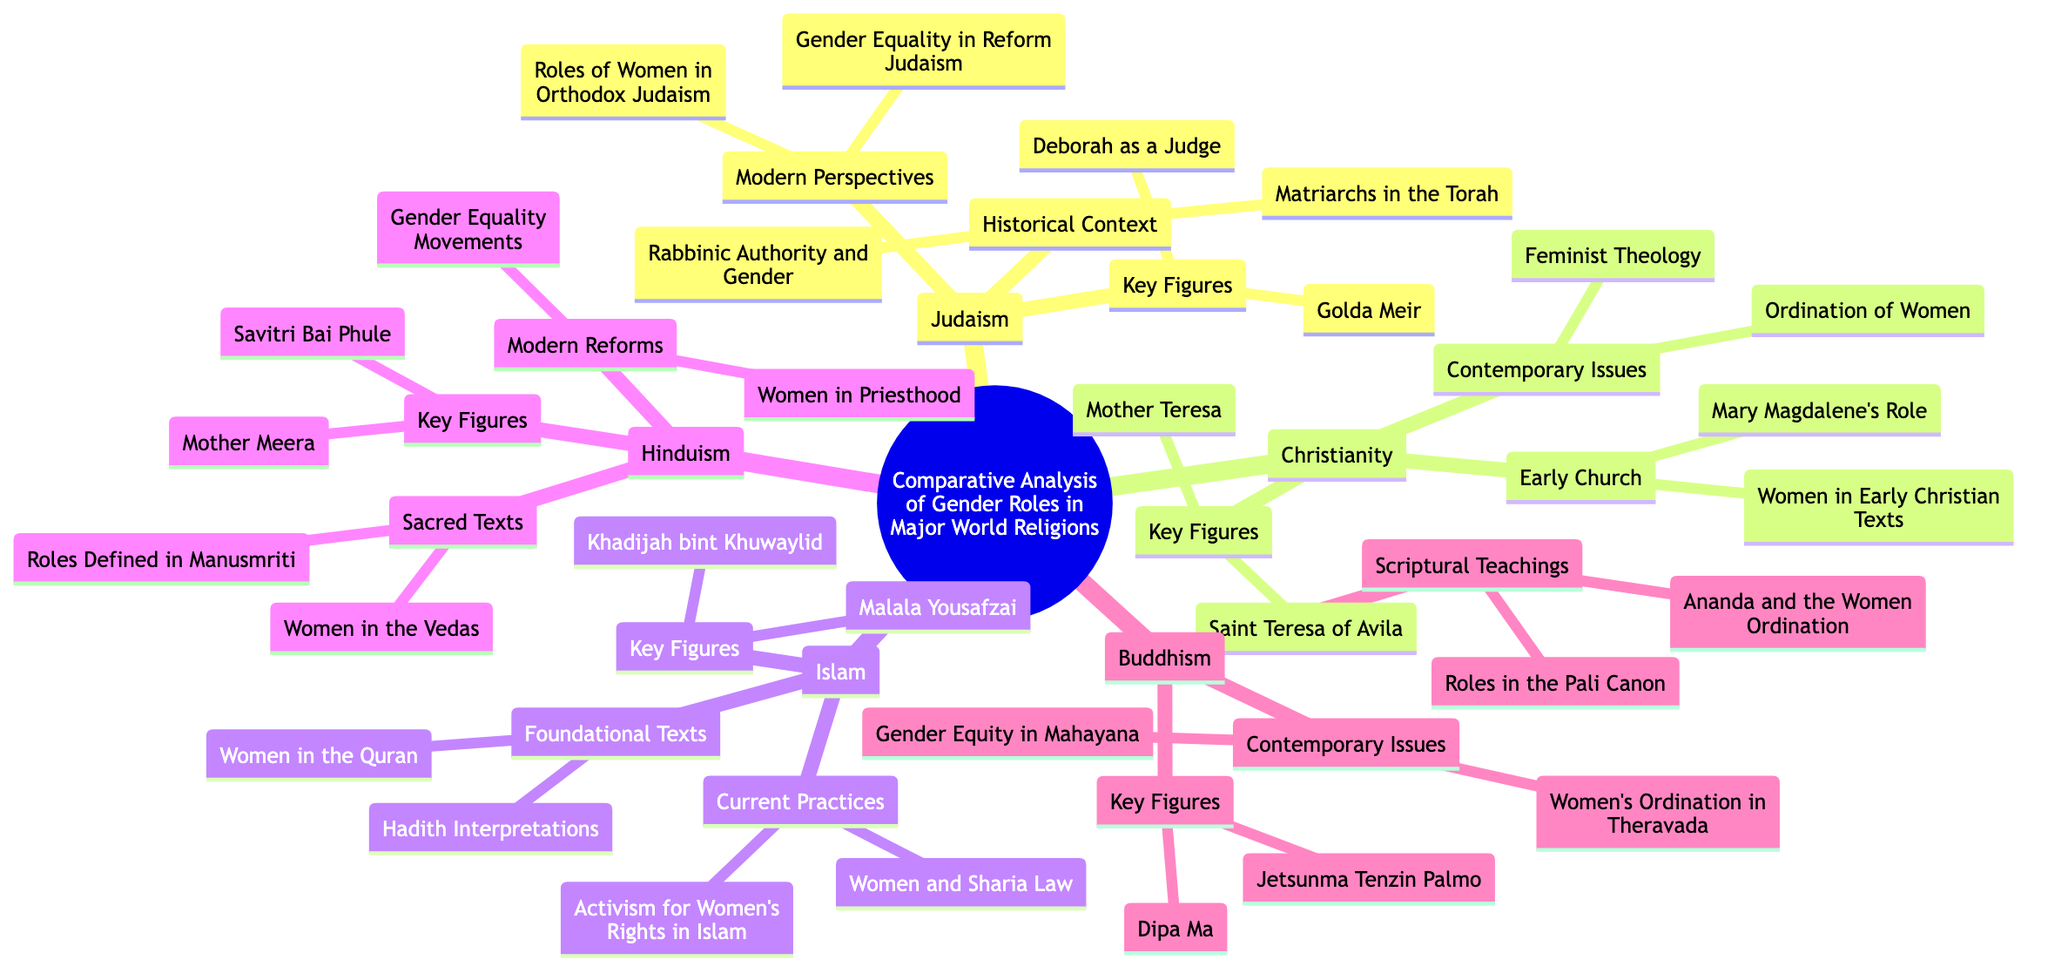What are the key figures in Christianity? To find the key figures within the Christianity branch, I look for the sub-branch labeled "Key Figures." In that sub-branch, the names listed are "Saint Teresa of Avila" and "Mother Teresa."
Answer: Saint Teresa of Avila, Mother Teresa How many major world religions are analyzed in this mind map? I need to count the main branches starting from the root. There are five branches (Judaism, Christianity, Islam, Hinduism, Buddhism) indicating five major world religions analyzed.
Answer: 5 Which religion mentions "Khadijah bint Khuwaylid" as a key figure? To find this, I look at the branch labeled "Islam" and then check its "Key Figures" sub-branch, which explicitly lists "Khadijah bint Khuwaylid."
Answer: Islam What aspect of gender roles is discussed under "Modern Reforms" in Hinduism? I refer to the Hinduism branch and locate the sub-branch labeled "Modern Reforms." In that sub-branch, the topics listed are "Gender Equality Movements" and "Women in Priesthood," both addressing modern reforms in gender roles.
Answer: Gender Equality Movements, Women in Priesthood What is a key focus under "Current Practices" in Islam? I check the "Current Practices" sub-branch under the Islam section of the mind map. It mentions "Women and Sharia Law" and "Activism for Women's Rights in Islam," making these the key focuses.
Answer: Women and Sharia Law, Activism for Women's Rights in Islam How does Buddhism address women's ordination? I find the "Contemporary Issues" sub-branch under Buddhism. There, it mentions "Women's Ordination in Theravada" and "Gender Equity in Mahayana," indicating Buddhism addresses women's ordination through these issues.
Answer: Women's Ordination in Theravada, Gender Equity in Mahayana Which role does "Mary Magdalene" represent in Christianity? I look at the "Early Church" sub-branch of Christianity, which mentions "Mary Magdalene's Role." This implies she is significant in the discussion of early roles of women in Christianity.
Answer: Mary Magdalene's Role What topic related to women is found in the foundational texts of Islam? Referring to the "Foundational Texts" sub-branch under Islam, I see the listed topics are "Women in the Quran" and "Hadith Interpretations," signifying that these topics concern women in foundational Islamic texts.
Answer: Women in the Quran, Hadith Interpretations 